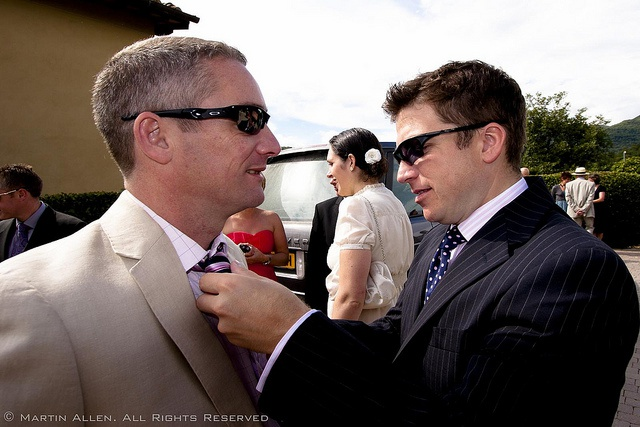Describe the objects in this image and their specific colors. I can see people in black, brown, gray, and maroon tones, people in black, gray, brown, and darkgray tones, people in black, darkgray, lightgray, and gray tones, car in black, lightgray, gray, and darkgray tones, and people in black, maroon, and gray tones in this image. 